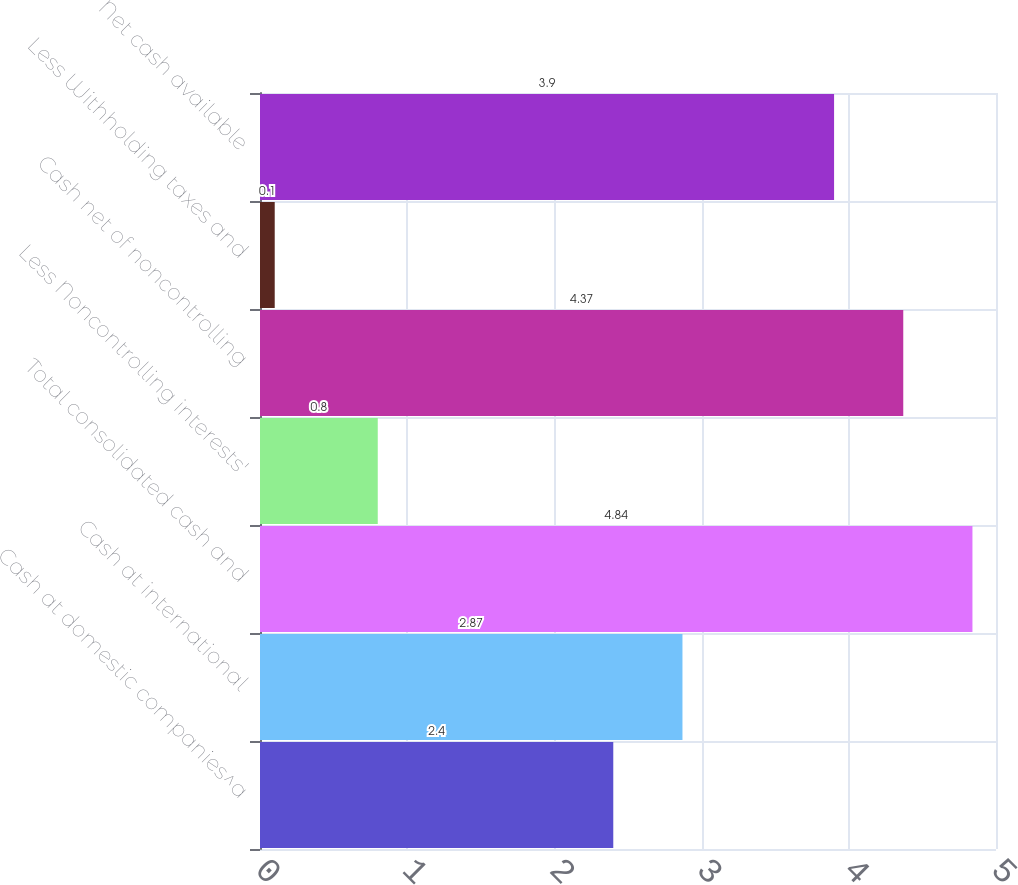<chart> <loc_0><loc_0><loc_500><loc_500><bar_chart><fcel>Cash at domestic companies^a<fcel>Cash at international<fcel>Total consolidated cash and<fcel>Less Noncontrolling interests'<fcel>Cash net of noncontrolling<fcel>Less Withholding taxes and<fcel>Net cash available<nl><fcel>2.4<fcel>2.87<fcel>4.84<fcel>0.8<fcel>4.37<fcel>0.1<fcel>3.9<nl></chart> 